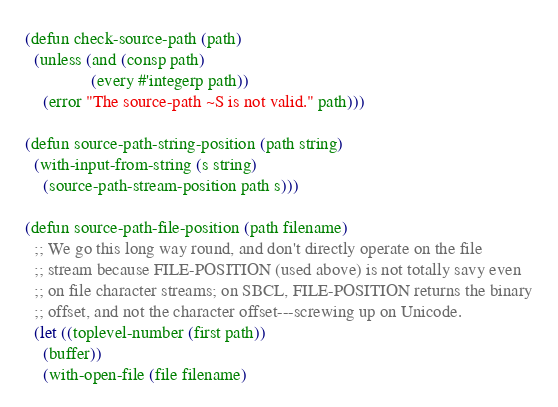<code> <loc_0><loc_0><loc_500><loc_500><_Lisp_>(defun check-source-path (path)
  (unless (and (consp path)
               (every #'integerp path))
    (error "The source-path ~S is not valid." path)))

(defun source-path-string-position (path string)
  (with-input-from-string (s string)
    (source-path-stream-position path s)))

(defun source-path-file-position (path filename)
  ;; We go this long way round, and don't directly operate on the file
  ;; stream because FILE-POSITION (used above) is not totally savy even
  ;; on file character streams; on SBCL, FILE-POSITION returns the binary
  ;; offset, and not the character offset---screwing up on Unicode.
  (let ((toplevel-number (first path))
	(buffer))
    (with-open-file (file filename)</code> 